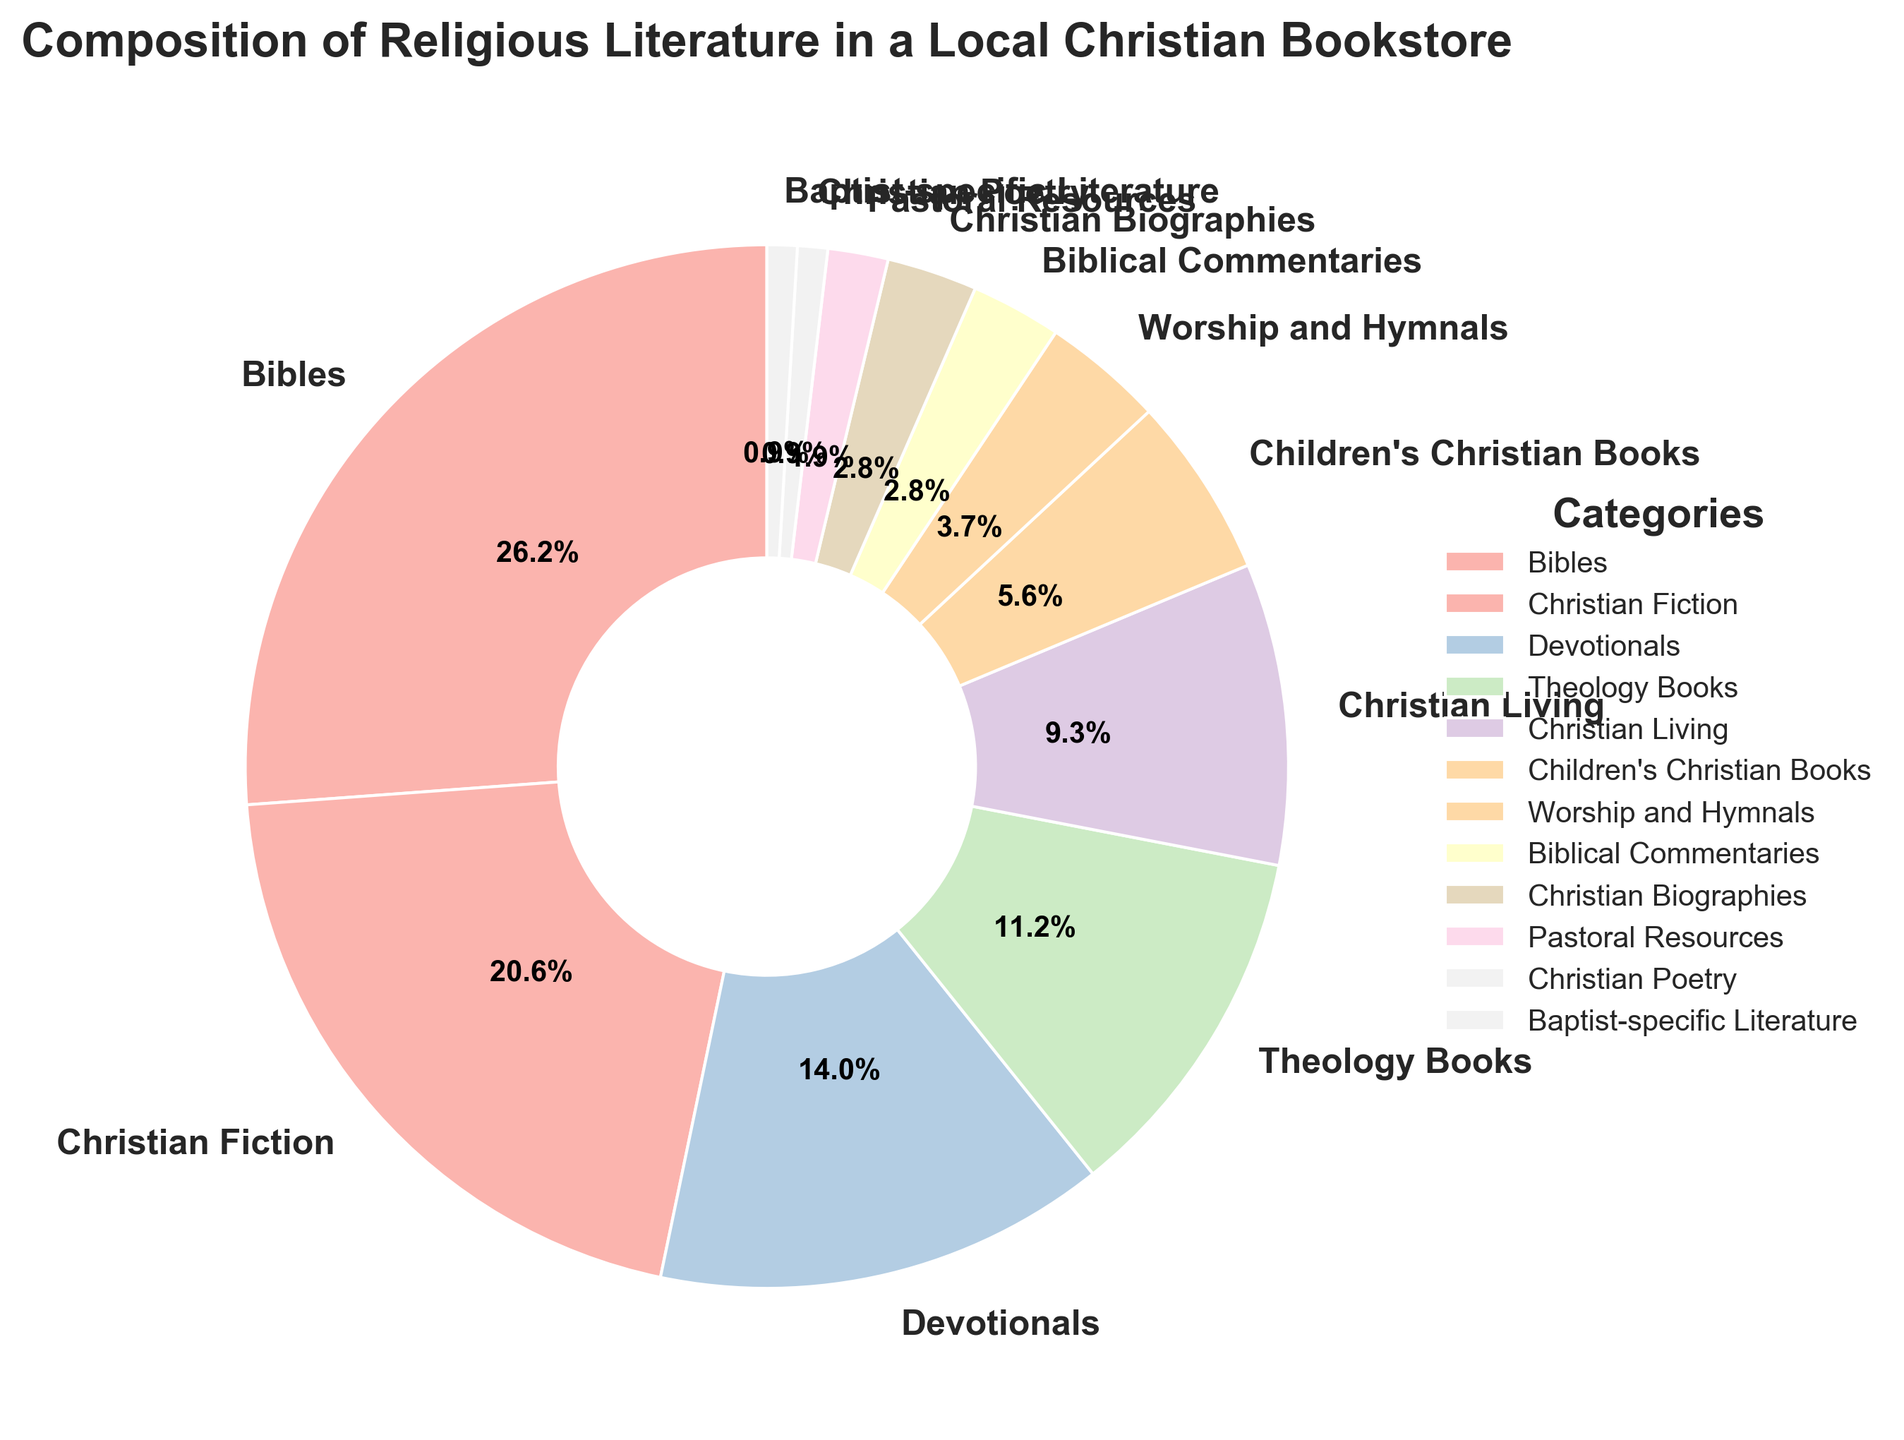What percentage of books are categorized as Christian Biographies? Look for the slice labeled "Christian Biographies" in the pie chart to see the percentage associated with it.
Answer: 3% What is the difference in percentage between Bibles and Christian Fiction? Refer to the pie chart to find the percentages of Bibles and Christian Fiction. Subtract the percentage of Christian Fiction from that of Bibles: 28% - 22%.
Answer: 6% If you combine the percentages of Theology Books and Christian Living, what is the total? Find the slices labeled "Theology Books" and "Christian Living" in the pie chart. Add their percentages: 12% (Theology Books) + 10% (Christian Living).
Answer: 22% Which category has a greater percentage: Devotionals or Children's Christian Books? Compare the percentages from the pie chart. Devotionals is 15%, and Children's Christian Books is 6%. Devotionals has a greater percentage.
Answer: Devotionals What is the combined percentage of the three smallest categories in the chart? Identify the three smallest categories by percentage: Christian Poetry (1%), Baptist-specific Literature (1%), and Pastoral Resources (2%). Add them up: 1% + 1% + 2%.
Answer: 4% How does the percentage for Worship and Hymnals compare to the percentage for Christian Living? Find these percentages in the pie chart. Worship and Hymnals is 4%, and Christian Living is 10%. Compare to see that Christian Living has a higher percentage.
Answer: Christian Living has a higher percentage If you sum the percentages of Bibles, Christian Fiction, and Devotionals, what is the result? Find the slices for Bibles (28%), Christian Fiction (22%), and Devotionals (15%). Add them together: 28% + 22% + 15%.
Answer: 65% Which category has the smallest representation, and what is its percentage? Look for the smallest slice in the pie chart, which is labeled "Christian Poetry" or "Baptist-specific Literature". Both have the same smallest percentage.
Answer: Christian Poetry and Baptist-specific Literature, 1% Is the category of Children's Christian Books larger than the combined percentage of Biblical Commentaries and Christian Biographies? Refer to the pie chart to get the percentages: Children's Christian Books (6%), Biblical Commentaries (3%), and Christian Biographies (3%). Add Biblical Commentaries and Christian Biographies: 3% + 3% = 6%. Compare this sum with Children's Christian Books.
Answer: They are equal What percentage of books are related to Christian Fiction and Theology Books combined? Add the percentages for these categories: Christian Fiction (22%) and Theology Books (12%).
Answer: 34% 